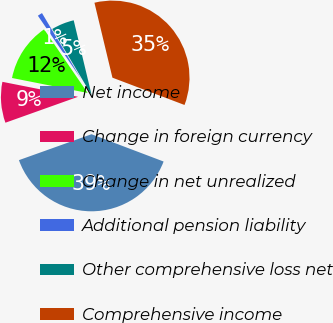Convert chart to OTSL. <chart><loc_0><loc_0><loc_500><loc_500><pie_chart><fcel>Net income<fcel>Change in foreign currency<fcel>Change in net unrealized<fcel>Additional pension liability<fcel>Other comprehensive loss net<fcel>Comprehensive income<nl><fcel>38.78%<fcel>8.57%<fcel>12.34%<fcel>1.01%<fcel>4.79%<fcel>34.51%<nl></chart> 